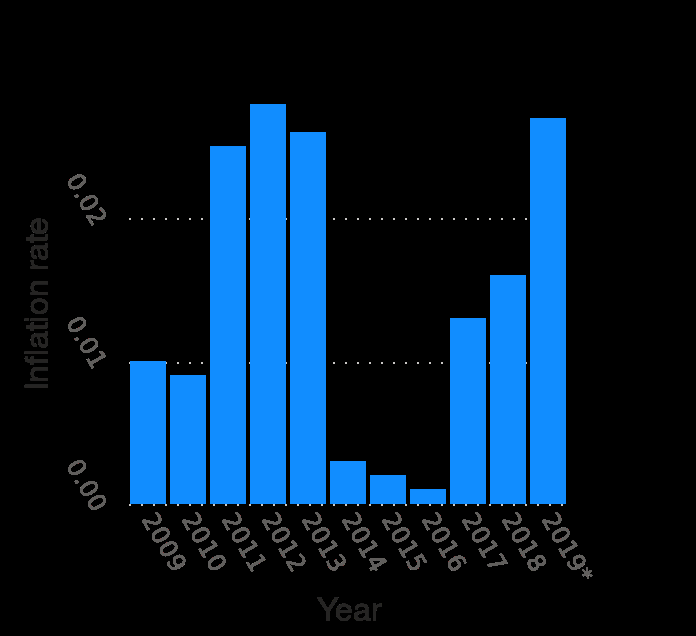<image>
Describe the following image in detail This is a bar diagram called Annual HICP inflation rate of the Netherlands from 2009 to 2019 (compared to the previous year). The y-axis shows Inflation rate on a linear scale with a minimum of 0.00 and a maximum of 0.02. A categorical scale with 2009 on one end and  at the other can be seen on the x-axis, labeled Year. Compared to the previous years, did the HICP inflation rates increase or decrease in 2012 and 2019?  The HICP inflation rates increased compared to the previous year with a growth of 0.02% in 2012 and 2019. What happened to the inflation rates from 2014 to 2016?  The inflation rates drastically dropped from 2014 to 2016, reaching 0.002. 